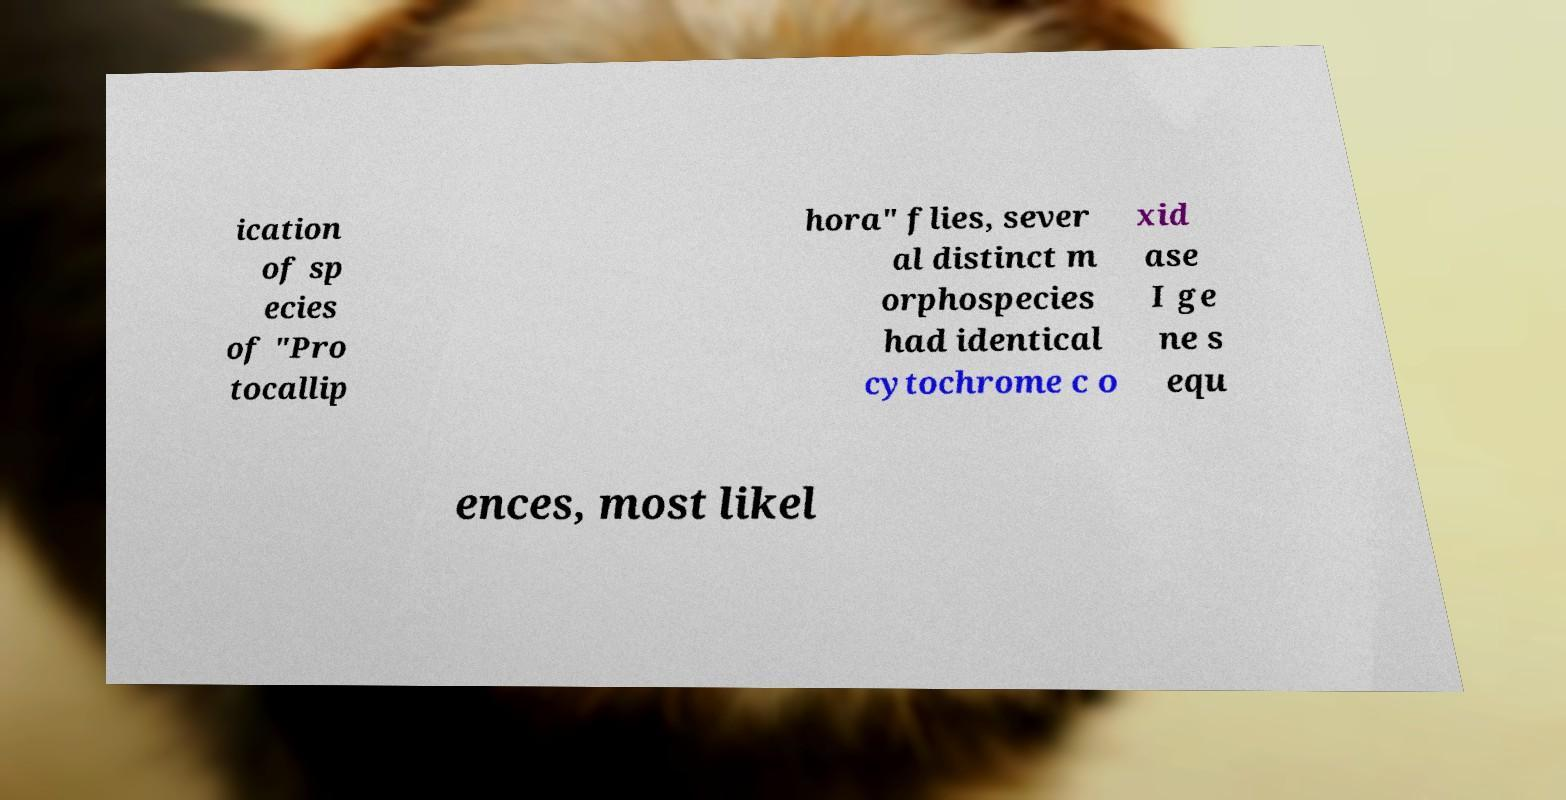Could you assist in decoding the text presented in this image and type it out clearly? ication of sp ecies of "Pro tocallip hora" flies, sever al distinct m orphospecies had identical cytochrome c o xid ase I ge ne s equ ences, most likel 